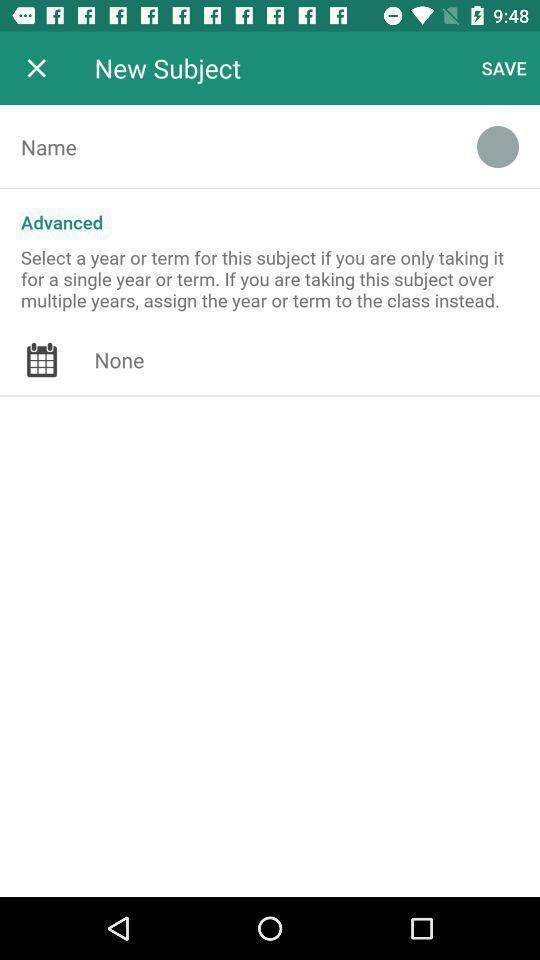Give me a narrative description of this picture. Screen displaying the new subject page. 